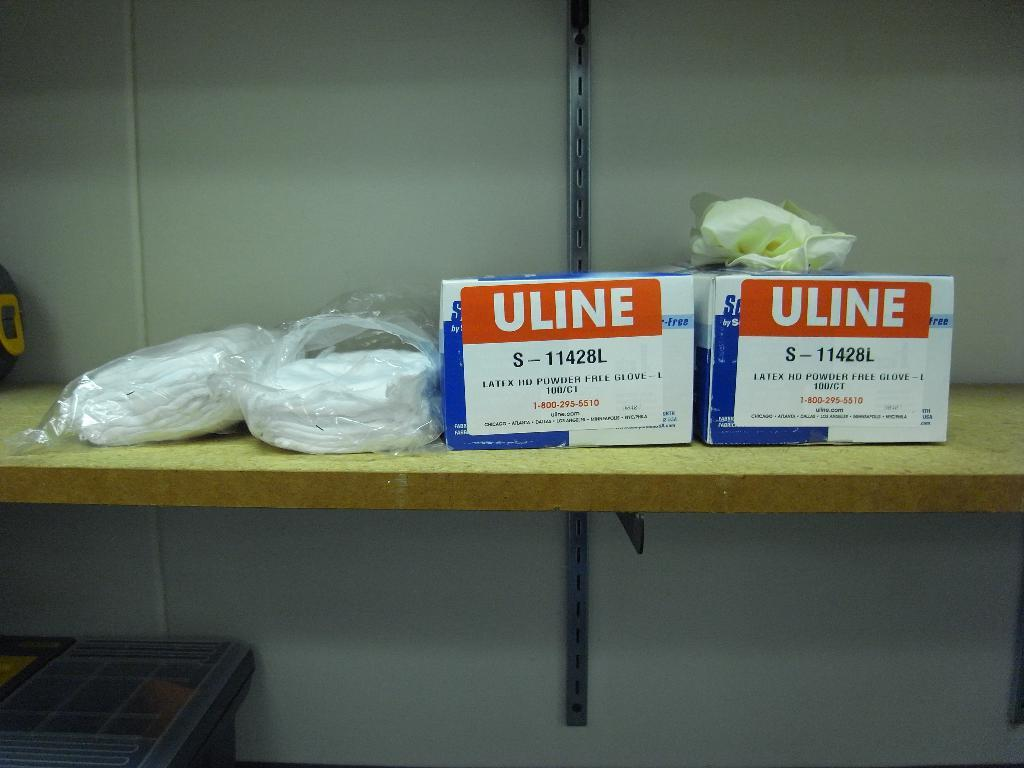What is the color of the stickers on the boxes in the image? The stickers on the boxes in the image are orange. How many boxes with orange color stickers are there in the image? There are two boxes with orange color stickers in the image. What can be seen on the left side of the image? There are clothes in polythene covers on the left side of the image. What type of society is depicted in the image? There is no society depicted in the image; it only shows two boxes with orange color stickers and clothes in polythene covers. What show is being performed in the image? There is no show being performed in the image; it only shows two boxes with orange color stickers and clothes in polythene covers. 